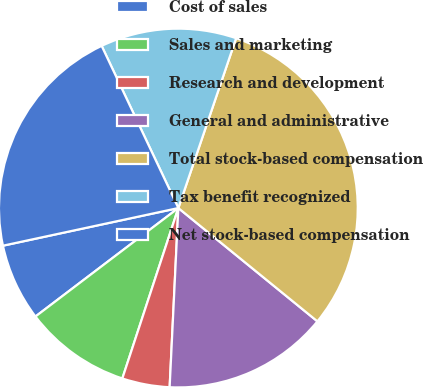Convert chart to OTSL. <chart><loc_0><loc_0><loc_500><loc_500><pie_chart><fcel>Cost of sales<fcel>Sales and marketing<fcel>Research and development<fcel>General and administrative<fcel>Total stock-based compensation<fcel>Tax benefit recognized<fcel>Net stock-based compensation<nl><fcel>6.97%<fcel>9.61%<fcel>4.28%<fcel>14.89%<fcel>30.66%<fcel>12.25%<fcel>21.33%<nl></chart> 